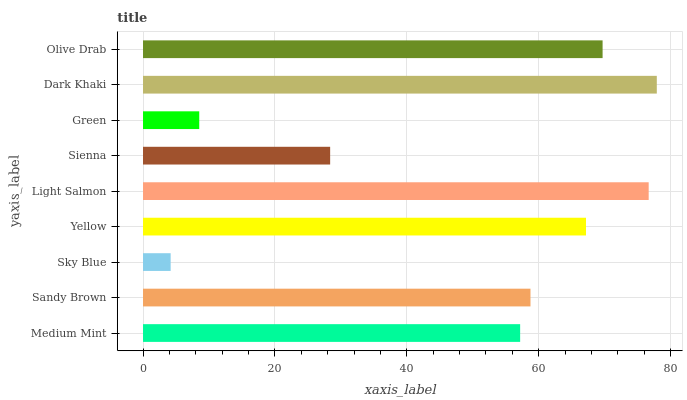Is Sky Blue the minimum?
Answer yes or no. Yes. Is Dark Khaki the maximum?
Answer yes or no. Yes. Is Sandy Brown the minimum?
Answer yes or no. No. Is Sandy Brown the maximum?
Answer yes or no. No. Is Sandy Brown greater than Medium Mint?
Answer yes or no. Yes. Is Medium Mint less than Sandy Brown?
Answer yes or no. Yes. Is Medium Mint greater than Sandy Brown?
Answer yes or no. No. Is Sandy Brown less than Medium Mint?
Answer yes or no. No. Is Sandy Brown the high median?
Answer yes or no. Yes. Is Sandy Brown the low median?
Answer yes or no. Yes. Is Sky Blue the high median?
Answer yes or no. No. Is Dark Khaki the low median?
Answer yes or no. No. 